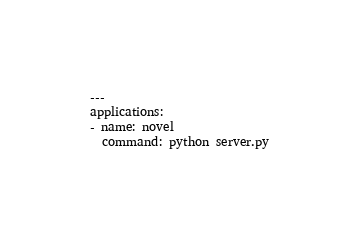<code> <loc_0><loc_0><loc_500><loc_500><_YAML_>---
applications:
- name: novel
  command: python server.py
</code> 